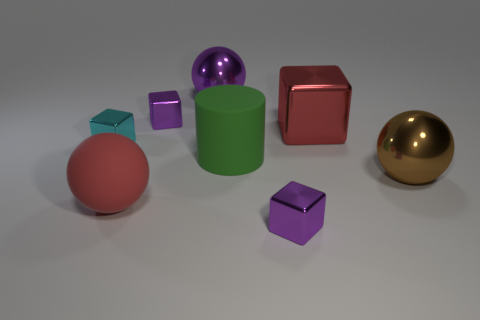Is the color of the rubber ball the same as the large cylinder?
Provide a succinct answer. No. Are there more shiny balls than green matte cylinders?
Your response must be concise. Yes. What number of other objects are there of the same material as the big cylinder?
Keep it short and to the point. 1. How many things are either large brown things or tiny purple shiny objects that are behind the big brown metal ball?
Provide a short and direct response. 2. Are there fewer big brown metal spheres than tiny brown cylinders?
Your response must be concise. No. There is a large metal sphere left of the matte object that is to the right of the small purple thing behind the cyan metal object; what is its color?
Provide a succinct answer. Purple. Is the material of the cyan cube the same as the brown object?
Make the answer very short. Yes. How many large purple balls are on the right side of the red sphere?
Provide a succinct answer. 1. The purple metal object that is the same shape as the big brown metallic thing is what size?
Give a very brief answer. Large. How many gray things are large things or small metal balls?
Your response must be concise. 0. 